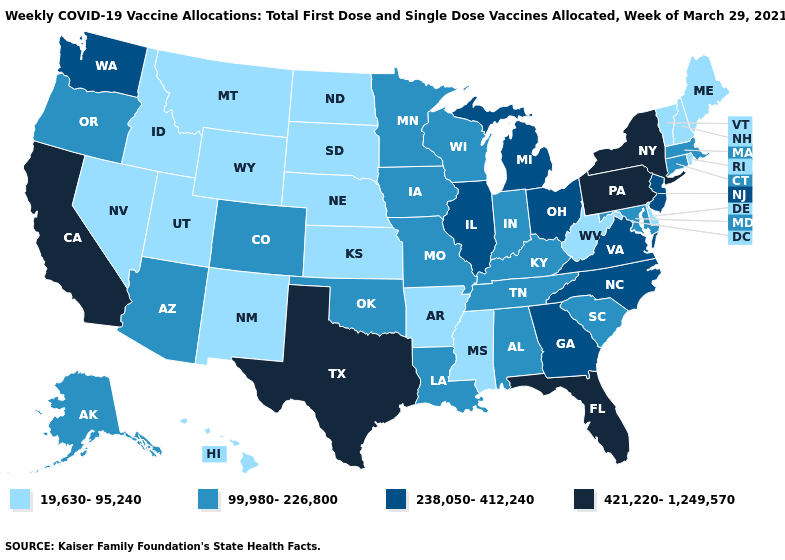What is the value of Washington?
Concise answer only. 238,050-412,240. What is the value of North Dakota?
Write a very short answer. 19,630-95,240. Name the states that have a value in the range 238,050-412,240?
Write a very short answer. Georgia, Illinois, Michigan, New Jersey, North Carolina, Ohio, Virginia, Washington. Does Missouri have the lowest value in the MidWest?
Quick response, please. No. Name the states that have a value in the range 99,980-226,800?
Answer briefly. Alabama, Alaska, Arizona, Colorado, Connecticut, Indiana, Iowa, Kentucky, Louisiana, Maryland, Massachusetts, Minnesota, Missouri, Oklahoma, Oregon, South Carolina, Tennessee, Wisconsin. What is the value of Utah?
Be succinct. 19,630-95,240. Name the states that have a value in the range 421,220-1,249,570?
Write a very short answer. California, Florida, New York, Pennsylvania, Texas. What is the value of California?
Write a very short answer. 421,220-1,249,570. Does the map have missing data?
Answer briefly. No. What is the lowest value in states that border New Hampshire?
Keep it brief. 19,630-95,240. Does the first symbol in the legend represent the smallest category?
Concise answer only. Yes. Does Oregon have the highest value in the USA?
Write a very short answer. No. What is the highest value in the USA?
Keep it brief. 421,220-1,249,570. Name the states that have a value in the range 19,630-95,240?
Concise answer only. Arkansas, Delaware, Hawaii, Idaho, Kansas, Maine, Mississippi, Montana, Nebraska, Nevada, New Hampshire, New Mexico, North Dakota, Rhode Island, South Dakota, Utah, Vermont, West Virginia, Wyoming. Among the states that border Wisconsin , does Minnesota have the lowest value?
Concise answer only. Yes. 